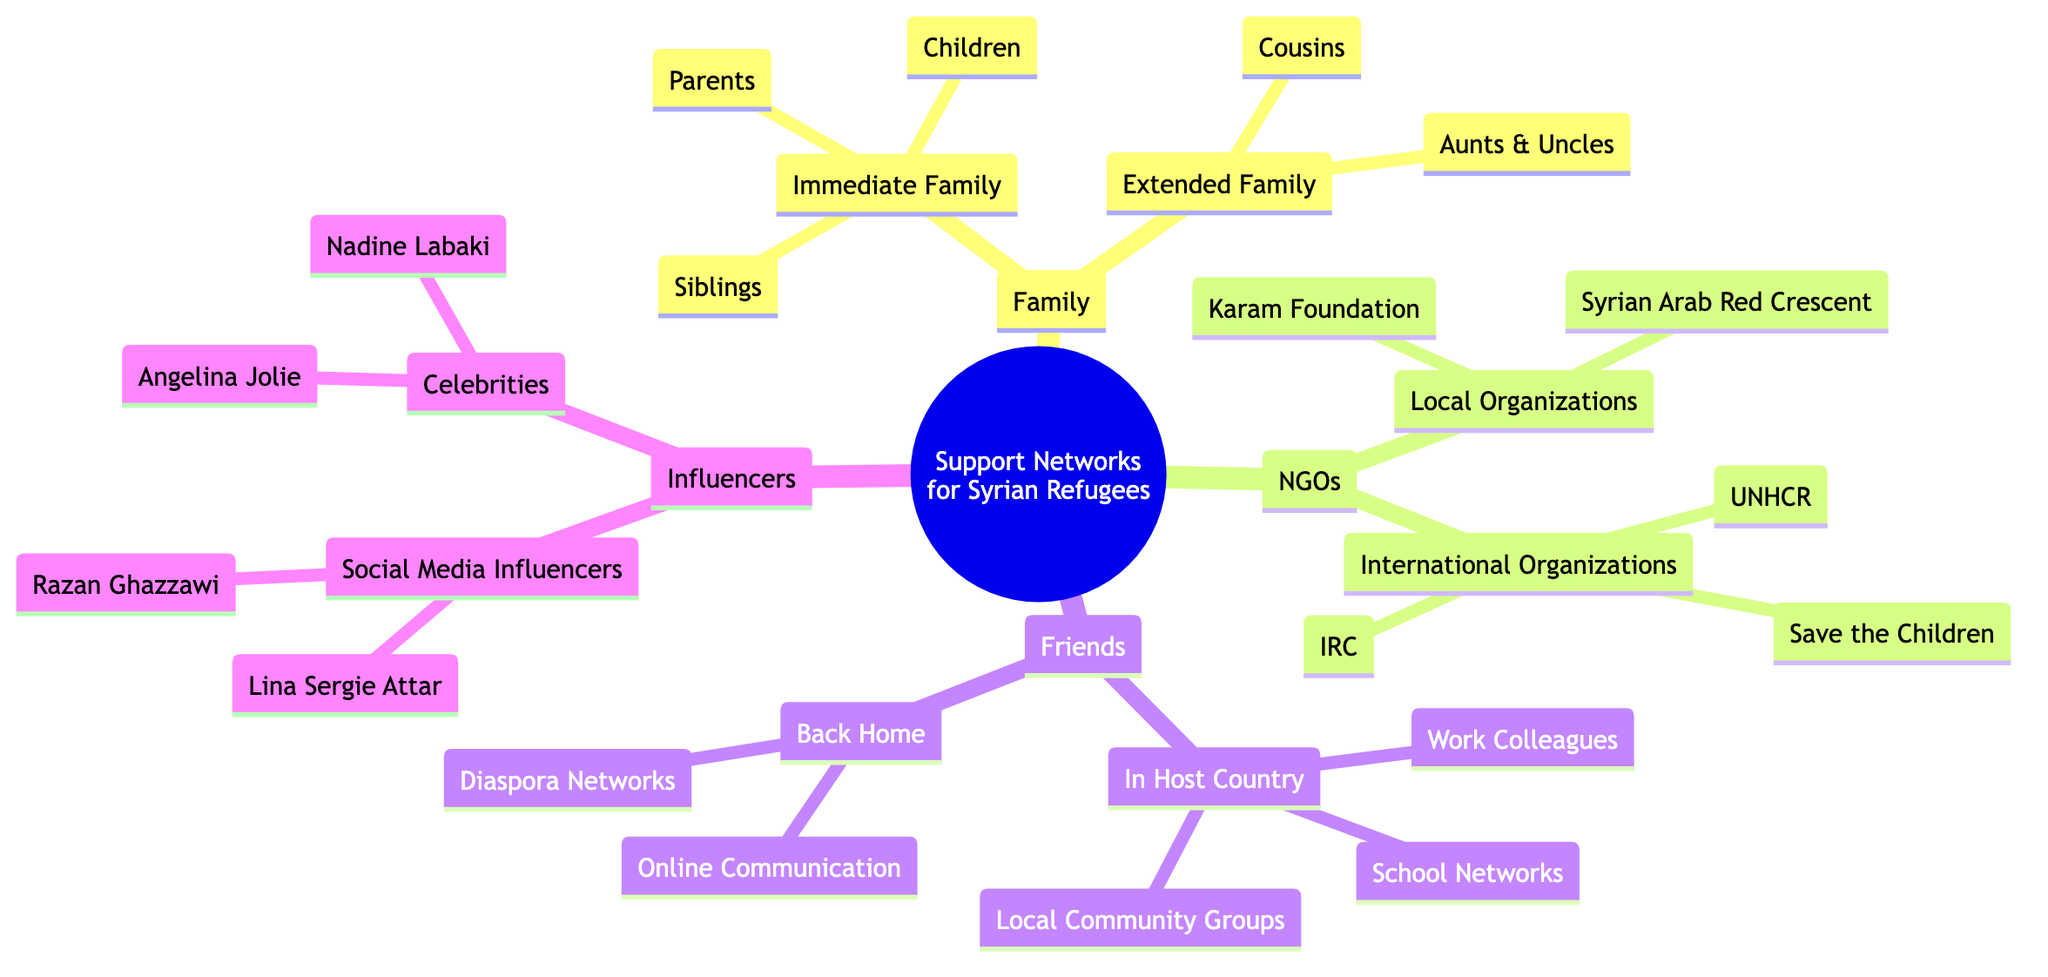What is the primary focus of the mind map? The primary focus of the mind map is "Support Networks for Syrian Refugees," which is the root node of the diagram. The branches extend to different types of support networks available to Syrian refugees.
Answer: Support Networks for Syrian Refugees How many types of support networks are identified in the diagram? There are four main branches stemming from the root node in the mind map: Family, NGOs, Friends, and Influencers. Counting these branches gives a total of four types of support networks.
Answer: 4 What is one example of an international organization that supports Syrian refugees? Looking at the "International Organizations" under the "NGOs" node, one can find "United Nations High Commissioner for Refugees (UNHCR)" listed as a key example.
Answer: United Nations High Commissioner for Refugees (UNHCR) Which group of friends provides support in the host country? Under the "Friends" node, the sub-node "In Host Country" includes "Local Community Groups," "School Networks," and "Work Colleagues," indicating that these groups provide support.
Answer: Local Community Groups Who is one social media influencer mentioned in the diagram? In the "Influencers" category, the sub-node "Social Media Influencers" lists "Lina Sergie Attar" as one of the individuals dedicated to advocating for Syrian refugees.
Answer: Lina Sergie Attar How many immediate family members are specified in the diagram? Under "Immediate Family," three specific types of family members are mentioned: "Parents," "Siblings," and "Children." Thus, the count of immediate family members is three.
Answer: 3 What relationship exists between "Local Organizations" and "NGOs"? "Local Organizations" is a sub-category under the "NGOs" category, indicating that local organizations are part of the broader support system provided by NGOs to assist Syrian refugees.
Answer: Sub-category Which celebrity is recognized as a UNHCR Goodwill Ambassador? In the "Celebrities" node of the "Influencers" branch, "Angelina Jolie" is specifically mentioned as the UNHCR Goodwill Ambassador, providing her support for the cause.
Answer: Angelina Jolie 